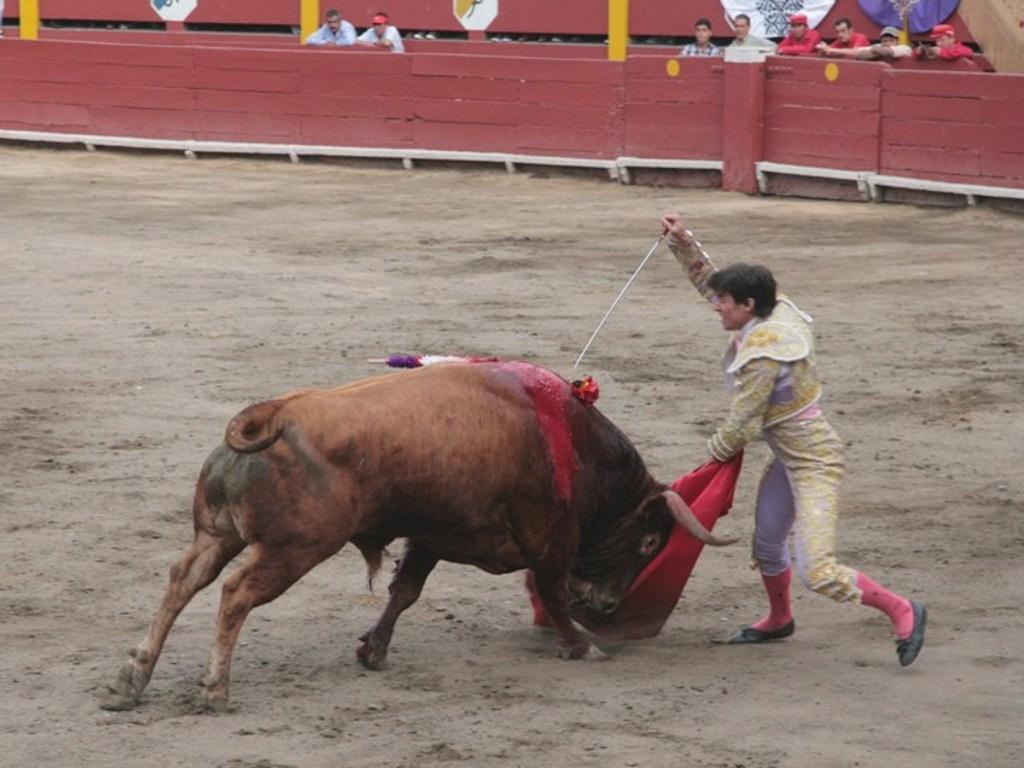In one or two sentences, can you explain what this image depicts? In this picture I can see a man standing and holding a sword and a red color cloth, there is a bull, and in the background there are few people standing and there is fence. 